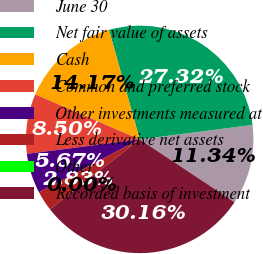Convert chart to OTSL. <chart><loc_0><loc_0><loc_500><loc_500><pie_chart><fcel>June 30<fcel>Net fair value of assets<fcel>Cash<fcel>Common and preferred stock<fcel>Other investments measured at<fcel>Less derivative net assets<fcel>Other<fcel>Recorded basis of investment<nl><fcel>11.34%<fcel>27.32%<fcel>14.17%<fcel>8.5%<fcel>5.67%<fcel>2.83%<fcel>0.0%<fcel>30.16%<nl></chart> 